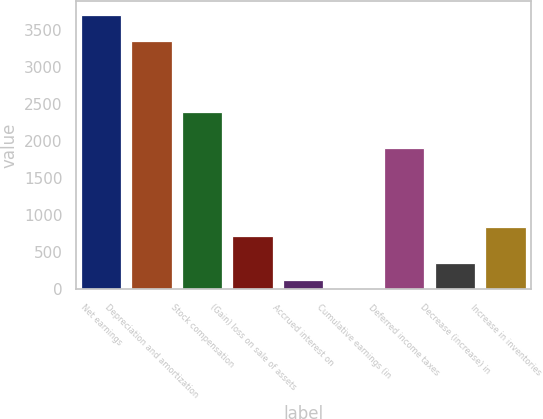<chart> <loc_0><loc_0><loc_500><loc_500><bar_chart><fcel>Net earnings<fcel>Depreciation and amortization<fcel>Stock compensation<fcel>(Gain) loss on sale of assets<fcel>Accrued interest on<fcel>Cumulative earnings (in<fcel>Deferred income taxes<fcel>Decrease (increase) in<fcel>Increase in inventories<nl><fcel>3708.49<fcel>3349.72<fcel>2393<fcel>718.74<fcel>120.79<fcel>1.2<fcel>1914.64<fcel>359.97<fcel>838.33<nl></chart> 